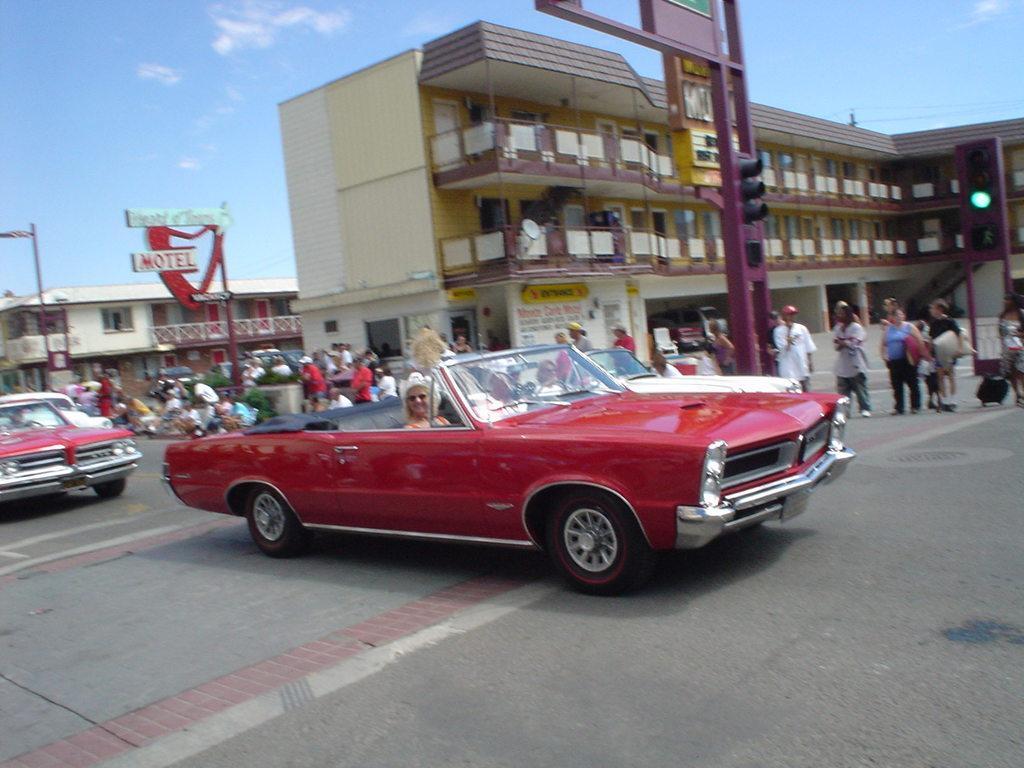Describe this image in one or two sentences. In the center of the image there is a woman in car. At the bottom of the image there is road. On the right side of the image we can see persons, traffic signals and building. On the left side of the image we can see building, persons, plants and vehicle. In the background we can see sky and clouds. 